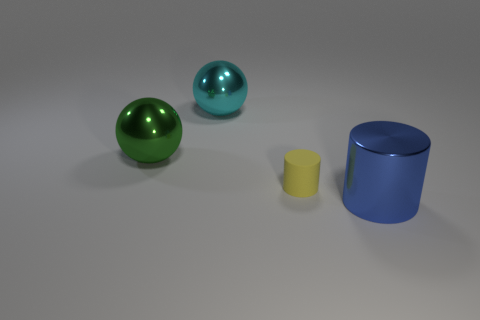What number of other objects are the same size as the blue metallic thing?
Your answer should be compact. 2. Are there any other things that have the same shape as the blue metallic object?
Your answer should be compact. Yes. There is another large metal thing that is the same shape as the large green thing; what color is it?
Your answer should be very brief. Cyan. What is the color of the sphere that is the same material as the green thing?
Offer a terse response. Cyan. Are there an equal number of shiny balls in front of the large blue metal cylinder and large cyan objects?
Offer a very short reply. No. Does the thing that is behind the green metal object have the same size as the blue shiny thing?
Give a very brief answer. Yes. There is a metallic ball that is the same size as the cyan thing; what is its color?
Offer a terse response. Green. Is there a blue cylinder that is behind the cylinder left of the metallic thing that is in front of the small cylinder?
Offer a terse response. No. There is a cylinder behind the big blue thing; what material is it?
Offer a very short reply. Rubber. Do the cyan metal thing and the big green thing behind the tiny thing have the same shape?
Your response must be concise. Yes. 